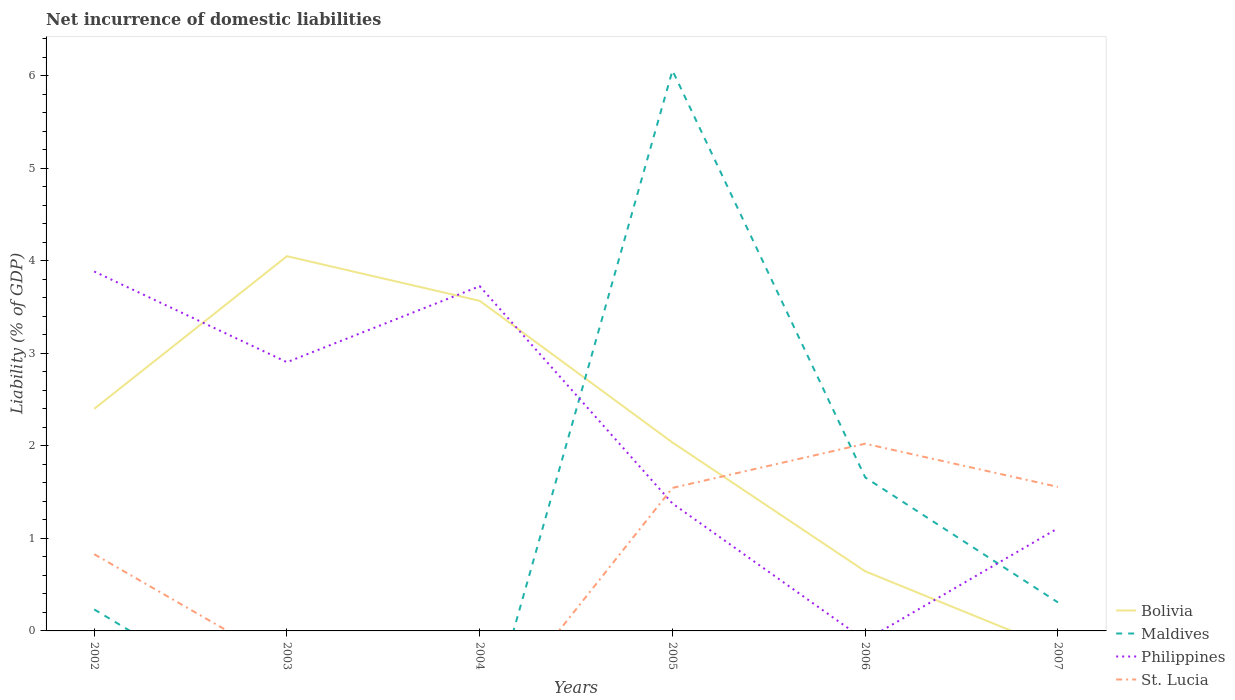How many different coloured lines are there?
Offer a terse response. 4. Is the number of lines equal to the number of legend labels?
Your answer should be compact. No. Across all years, what is the maximum net incurrence of domestic liabilities in St. Lucia?
Offer a terse response. 0. What is the total net incurrence of domestic liabilities in St. Lucia in the graph?
Your answer should be compact. -0.72. What is the difference between the highest and the second highest net incurrence of domestic liabilities in St. Lucia?
Your answer should be very brief. 2.02. What is the difference between the highest and the lowest net incurrence of domestic liabilities in St. Lucia?
Your answer should be very brief. 3. Is the net incurrence of domestic liabilities in Maldives strictly greater than the net incurrence of domestic liabilities in Bolivia over the years?
Offer a terse response. No. Does the graph contain grids?
Provide a succinct answer. No. Where does the legend appear in the graph?
Ensure brevity in your answer.  Bottom right. How are the legend labels stacked?
Make the answer very short. Vertical. What is the title of the graph?
Offer a very short reply. Net incurrence of domestic liabilities. What is the label or title of the X-axis?
Keep it short and to the point. Years. What is the label or title of the Y-axis?
Your response must be concise. Liability (% of GDP). What is the Liability (% of GDP) of Bolivia in 2002?
Offer a very short reply. 2.4. What is the Liability (% of GDP) of Maldives in 2002?
Provide a succinct answer. 0.23. What is the Liability (% of GDP) of Philippines in 2002?
Make the answer very short. 3.88. What is the Liability (% of GDP) in St. Lucia in 2002?
Your answer should be very brief. 0.83. What is the Liability (% of GDP) of Bolivia in 2003?
Provide a short and direct response. 4.05. What is the Liability (% of GDP) of Philippines in 2003?
Ensure brevity in your answer.  2.9. What is the Liability (% of GDP) in Bolivia in 2004?
Offer a terse response. 3.57. What is the Liability (% of GDP) of Maldives in 2004?
Your answer should be very brief. 0. What is the Liability (% of GDP) of Philippines in 2004?
Make the answer very short. 3.72. What is the Liability (% of GDP) of Bolivia in 2005?
Offer a very short reply. 2.04. What is the Liability (% of GDP) of Maldives in 2005?
Provide a short and direct response. 6.06. What is the Liability (% of GDP) of Philippines in 2005?
Keep it short and to the point. 1.38. What is the Liability (% of GDP) of St. Lucia in 2005?
Your response must be concise. 1.55. What is the Liability (% of GDP) of Bolivia in 2006?
Offer a very short reply. 0.64. What is the Liability (% of GDP) in Maldives in 2006?
Make the answer very short. 1.66. What is the Liability (% of GDP) of St. Lucia in 2006?
Make the answer very short. 2.02. What is the Liability (% of GDP) in Bolivia in 2007?
Give a very brief answer. 0. What is the Liability (% of GDP) in Maldives in 2007?
Your answer should be very brief. 0.31. What is the Liability (% of GDP) of Philippines in 2007?
Provide a succinct answer. 1.11. What is the Liability (% of GDP) of St. Lucia in 2007?
Give a very brief answer. 1.56. Across all years, what is the maximum Liability (% of GDP) in Bolivia?
Your response must be concise. 4.05. Across all years, what is the maximum Liability (% of GDP) in Maldives?
Give a very brief answer. 6.06. Across all years, what is the maximum Liability (% of GDP) in Philippines?
Offer a very short reply. 3.88. Across all years, what is the maximum Liability (% of GDP) in St. Lucia?
Give a very brief answer. 2.02. Across all years, what is the minimum Liability (% of GDP) in Bolivia?
Give a very brief answer. 0. Across all years, what is the minimum Liability (% of GDP) of Maldives?
Provide a succinct answer. 0. Across all years, what is the minimum Liability (% of GDP) in St. Lucia?
Offer a terse response. 0. What is the total Liability (% of GDP) in Bolivia in the graph?
Your answer should be very brief. 12.7. What is the total Liability (% of GDP) of Maldives in the graph?
Offer a very short reply. 8.25. What is the total Liability (% of GDP) in Philippines in the graph?
Your answer should be very brief. 13. What is the total Liability (% of GDP) of St. Lucia in the graph?
Offer a very short reply. 5.95. What is the difference between the Liability (% of GDP) in Bolivia in 2002 and that in 2003?
Make the answer very short. -1.65. What is the difference between the Liability (% of GDP) in Philippines in 2002 and that in 2003?
Make the answer very short. 0.98. What is the difference between the Liability (% of GDP) in Bolivia in 2002 and that in 2004?
Provide a succinct answer. -1.17. What is the difference between the Liability (% of GDP) in Philippines in 2002 and that in 2004?
Offer a very short reply. 0.16. What is the difference between the Liability (% of GDP) in Bolivia in 2002 and that in 2005?
Offer a very short reply. 0.36. What is the difference between the Liability (% of GDP) in Maldives in 2002 and that in 2005?
Your answer should be very brief. -5.82. What is the difference between the Liability (% of GDP) in Philippines in 2002 and that in 2005?
Provide a succinct answer. 2.51. What is the difference between the Liability (% of GDP) of St. Lucia in 2002 and that in 2005?
Make the answer very short. -0.72. What is the difference between the Liability (% of GDP) of Bolivia in 2002 and that in 2006?
Give a very brief answer. 1.76. What is the difference between the Liability (% of GDP) in Maldives in 2002 and that in 2006?
Provide a succinct answer. -1.43. What is the difference between the Liability (% of GDP) of St. Lucia in 2002 and that in 2006?
Offer a very short reply. -1.19. What is the difference between the Liability (% of GDP) of Maldives in 2002 and that in 2007?
Ensure brevity in your answer.  -0.08. What is the difference between the Liability (% of GDP) in Philippines in 2002 and that in 2007?
Your response must be concise. 2.77. What is the difference between the Liability (% of GDP) of St. Lucia in 2002 and that in 2007?
Your answer should be very brief. -0.73. What is the difference between the Liability (% of GDP) in Bolivia in 2003 and that in 2004?
Make the answer very short. 0.48. What is the difference between the Liability (% of GDP) in Philippines in 2003 and that in 2004?
Make the answer very short. -0.82. What is the difference between the Liability (% of GDP) of Bolivia in 2003 and that in 2005?
Keep it short and to the point. 2.01. What is the difference between the Liability (% of GDP) of Philippines in 2003 and that in 2005?
Keep it short and to the point. 1.53. What is the difference between the Liability (% of GDP) of Bolivia in 2003 and that in 2006?
Your answer should be very brief. 3.4. What is the difference between the Liability (% of GDP) in Philippines in 2003 and that in 2007?
Keep it short and to the point. 1.79. What is the difference between the Liability (% of GDP) in Bolivia in 2004 and that in 2005?
Offer a very short reply. 1.53. What is the difference between the Liability (% of GDP) in Philippines in 2004 and that in 2005?
Offer a terse response. 2.35. What is the difference between the Liability (% of GDP) in Bolivia in 2004 and that in 2006?
Provide a succinct answer. 2.92. What is the difference between the Liability (% of GDP) in Philippines in 2004 and that in 2007?
Keep it short and to the point. 2.61. What is the difference between the Liability (% of GDP) in Bolivia in 2005 and that in 2006?
Give a very brief answer. 1.39. What is the difference between the Liability (% of GDP) of Maldives in 2005 and that in 2006?
Keep it short and to the point. 4.4. What is the difference between the Liability (% of GDP) in St. Lucia in 2005 and that in 2006?
Ensure brevity in your answer.  -0.48. What is the difference between the Liability (% of GDP) of Maldives in 2005 and that in 2007?
Give a very brief answer. 5.75. What is the difference between the Liability (% of GDP) of Philippines in 2005 and that in 2007?
Your response must be concise. 0.27. What is the difference between the Liability (% of GDP) of St. Lucia in 2005 and that in 2007?
Your answer should be compact. -0.01. What is the difference between the Liability (% of GDP) of Maldives in 2006 and that in 2007?
Keep it short and to the point. 1.35. What is the difference between the Liability (% of GDP) in St. Lucia in 2006 and that in 2007?
Make the answer very short. 0.47. What is the difference between the Liability (% of GDP) in Bolivia in 2002 and the Liability (% of GDP) in Philippines in 2003?
Your answer should be compact. -0.5. What is the difference between the Liability (% of GDP) of Maldives in 2002 and the Liability (% of GDP) of Philippines in 2003?
Your response must be concise. -2.67. What is the difference between the Liability (% of GDP) of Bolivia in 2002 and the Liability (% of GDP) of Philippines in 2004?
Keep it short and to the point. -1.32. What is the difference between the Liability (% of GDP) in Maldives in 2002 and the Liability (% of GDP) in Philippines in 2004?
Keep it short and to the point. -3.49. What is the difference between the Liability (% of GDP) of Bolivia in 2002 and the Liability (% of GDP) of Maldives in 2005?
Give a very brief answer. -3.66. What is the difference between the Liability (% of GDP) in Bolivia in 2002 and the Liability (% of GDP) in Philippines in 2005?
Offer a very short reply. 1.02. What is the difference between the Liability (% of GDP) in Bolivia in 2002 and the Liability (% of GDP) in St. Lucia in 2005?
Your answer should be compact. 0.85. What is the difference between the Liability (% of GDP) in Maldives in 2002 and the Liability (% of GDP) in Philippines in 2005?
Ensure brevity in your answer.  -1.14. What is the difference between the Liability (% of GDP) of Maldives in 2002 and the Liability (% of GDP) of St. Lucia in 2005?
Your answer should be very brief. -1.31. What is the difference between the Liability (% of GDP) in Philippines in 2002 and the Liability (% of GDP) in St. Lucia in 2005?
Ensure brevity in your answer.  2.34. What is the difference between the Liability (% of GDP) in Bolivia in 2002 and the Liability (% of GDP) in Maldives in 2006?
Your answer should be very brief. 0.74. What is the difference between the Liability (% of GDP) in Bolivia in 2002 and the Liability (% of GDP) in St. Lucia in 2006?
Provide a succinct answer. 0.38. What is the difference between the Liability (% of GDP) of Maldives in 2002 and the Liability (% of GDP) of St. Lucia in 2006?
Provide a succinct answer. -1.79. What is the difference between the Liability (% of GDP) in Philippines in 2002 and the Liability (% of GDP) in St. Lucia in 2006?
Keep it short and to the point. 1.86. What is the difference between the Liability (% of GDP) of Bolivia in 2002 and the Liability (% of GDP) of Maldives in 2007?
Keep it short and to the point. 2.09. What is the difference between the Liability (% of GDP) in Bolivia in 2002 and the Liability (% of GDP) in Philippines in 2007?
Your answer should be very brief. 1.29. What is the difference between the Liability (% of GDP) of Bolivia in 2002 and the Liability (% of GDP) of St. Lucia in 2007?
Ensure brevity in your answer.  0.84. What is the difference between the Liability (% of GDP) of Maldives in 2002 and the Liability (% of GDP) of Philippines in 2007?
Your answer should be very brief. -0.88. What is the difference between the Liability (% of GDP) in Maldives in 2002 and the Liability (% of GDP) in St. Lucia in 2007?
Give a very brief answer. -1.32. What is the difference between the Liability (% of GDP) of Philippines in 2002 and the Liability (% of GDP) of St. Lucia in 2007?
Your answer should be compact. 2.33. What is the difference between the Liability (% of GDP) of Bolivia in 2003 and the Liability (% of GDP) of Philippines in 2004?
Ensure brevity in your answer.  0.32. What is the difference between the Liability (% of GDP) in Bolivia in 2003 and the Liability (% of GDP) in Maldives in 2005?
Your answer should be very brief. -2.01. What is the difference between the Liability (% of GDP) of Bolivia in 2003 and the Liability (% of GDP) of Philippines in 2005?
Keep it short and to the point. 2.67. What is the difference between the Liability (% of GDP) in Bolivia in 2003 and the Liability (% of GDP) in St. Lucia in 2005?
Your answer should be compact. 2.5. What is the difference between the Liability (% of GDP) in Philippines in 2003 and the Liability (% of GDP) in St. Lucia in 2005?
Your answer should be very brief. 1.36. What is the difference between the Liability (% of GDP) of Bolivia in 2003 and the Liability (% of GDP) of Maldives in 2006?
Provide a succinct answer. 2.39. What is the difference between the Liability (% of GDP) in Bolivia in 2003 and the Liability (% of GDP) in St. Lucia in 2006?
Your answer should be very brief. 2.03. What is the difference between the Liability (% of GDP) in Philippines in 2003 and the Liability (% of GDP) in St. Lucia in 2006?
Your answer should be compact. 0.88. What is the difference between the Liability (% of GDP) in Bolivia in 2003 and the Liability (% of GDP) in Maldives in 2007?
Offer a terse response. 3.74. What is the difference between the Liability (% of GDP) in Bolivia in 2003 and the Liability (% of GDP) in Philippines in 2007?
Your answer should be very brief. 2.94. What is the difference between the Liability (% of GDP) in Bolivia in 2003 and the Liability (% of GDP) in St. Lucia in 2007?
Offer a very short reply. 2.49. What is the difference between the Liability (% of GDP) in Philippines in 2003 and the Liability (% of GDP) in St. Lucia in 2007?
Offer a terse response. 1.35. What is the difference between the Liability (% of GDP) of Bolivia in 2004 and the Liability (% of GDP) of Maldives in 2005?
Provide a succinct answer. -2.49. What is the difference between the Liability (% of GDP) in Bolivia in 2004 and the Liability (% of GDP) in Philippines in 2005?
Ensure brevity in your answer.  2.19. What is the difference between the Liability (% of GDP) of Bolivia in 2004 and the Liability (% of GDP) of St. Lucia in 2005?
Offer a terse response. 2.02. What is the difference between the Liability (% of GDP) in Philippines in 2004 and the Liability (% of GDP) in St. Lucia in 2005?
Give a very brief answer. 2.18. What is the difference between the Liability (% of GDP) in Bolivia in 2004 and the Liability (% of GDP) in Maldives in 2006?
Your answer should be compact. 1.91. What is the difference between the Liability (% of GDP) in Bolivia in 2004 and the Liability (% of GDP) in St. Lucia in 2006?
Provide a succinct answer. 1.54. What is the difference between the Liability (% of GDP) of Philippines in 2004 and the Liability (% of GDP) of St. Lucia in 2006?
Give a very brief answer. 1.7. What is the difference between the Liability (% of GDP) in Bolivia in 2004 and the Liability (% of GDP) in Maldives in 2007?
Provide a short and direct response. 3.26. What is the difference between the Liability (% of GDP) in Bolivia in 2004 and the Liability (% of GDP) in Philippines in 2007?
Ensure brevity in your answer.  2.46. What is the difference between the Liability (% of GDP) in Bolivia in 2004 and the Liability (% of GDP) in St. Lucia in 2007?
Keep it short and to the point. 2.01. What is the difference between the Liability (% of GDP) in Philippines in 2004 and the Liability (% of GDP) in St. Lucia in 2007?
Give a very brief answer. 2.17. What is the difference between the Liability (% of GDP) of Bolivia in 2005 and the Liability (% of GDP) of Maldives in 2006?
Your answer should be very brief. 0.38. What is the difference between the Liability (% of GDP) of Bolivia in 2005 and the Liability (% of GDP) of St. Lucia in 2006?
Keep it short and to the point. 0.01. What is the difference between the Liability (% of GDP) of Maldives in 2005 and the Liability (% of GDP) of St. Lucia in 2006?
Ensure brevity in your answer.  4.03. What is the difference between the Liability (% of GDP) of Philippines in 2005 and the Liability (% of GDP) of St. Lucia in 2006?
Offer a very short reply. -0.65. What is the difference between the Liability (% of GDP) of Bolivia in 2005 and the Liability (% of GDP) of Maldives in 2007?
Give a very brief answer. 1.73. What is the difference between the Liability (% of GDP) of Bolivia in 2005 and the Liability (% of GDP) of Philippines in 2007?
Ensure brevity in your answer.  0.93. What is the difference between the Liability (% of GDP) in Bolivia in 2005 and the Liability (% of GDP) in St. Lucia in 2007?
Your answer should be compact. 0.48. What is the difference between the Liability (% of GDP) of Maldives in 2005 and the Liability (% of GDP) of Philippines in 2007?
Make the answer very short. 4.95. What is the difference between the Liability (% of GDP) in Maldives in 2005 and the Liability (% of GDP) in St. Lucia in 2007?
Your response must be concise. 4.5. What is the difference between the Liability (% of GDP) of Philippines in 2005 and the Liability (% of GDP) of St. Lucia in 2007?
Provide a short and direct response. -0.18. What is the difference between the Liability (% of GDP) in Bolivia in 2006 and the Liability (% of GDP) in Maldives in 2007?
Provide a short and direct response. 0.34. What is the difference between the Liability (% of GDP) in Bolivia in 2006 and the Liability (% of GDP) in Philippines in 2007?
Your answer should be compact. -0.47. What is the difference between the Liability (% of GDP) of Bolivia in 2006 and the Liability (% of GDP) of St. Lucia in 2007?
Your answer should be compact. -0.91. What is the difference between the Liability (% of GDP) of Maldives in 2006 and the Liability (% of GDP) of Philippines in 2007?
Give a very brief answer. 0.55. What is the difference between the Liability (% of GDP) of Maldives in 2006 and the Liability (% of GDP) of St. Lucia in 2007?
Offer a terse response. 0.1. What is the average Liability (% of GDP) in Bolivia per year?
Offer a terse response. 2.12. What is the average Liability (% of GDP) in Maldives per year?
Give a very brief answer. 1.38. What is the average Liability (% of GDP) in Philippines per year?
Provide a short and direct response. 2.17. In the year 2002, what is the difference between the Liability (% of GDP) in Bolivia and Liability (% of GDP) in Maldives?
Your answer should be very brief. 2.17. In the year 2002, what is the difference between the Liability (% of GDP) of Bolivia and Liability (% of GDP) of Philippines?
Your answer should be very brief. -1.48. In the year 2002, what is the difference between the Liability (% of GDP) of Bolivia and Liability (% of GDP) of St. Lucia?
Provide a short and direct response. 1.57. In the year 2002, what is the difference between the Liability (% of GDP) of Maldives and Liability (% of GDP) of Philippines?
Offer a terse response. -3.65. In the year 2002, what is the difference between the Liability (% of GDP) of Maldives and Liability (% of GDP) of St. Lucia?
Provide a short and direct response. -0.6. In the year 2002, what is the difference between the Liability (% of GDP) of Philippines and Liability (% of GDP) of St. Lucia?
Your response must be concise. 3.05. In the year 2003, what is the difference between the Liability (% of GDP) in Bolivia and Liability (% of GDP) in Philippines?
Your answer should be compact. 1.15. In the year 2004, what is the difference between the Liability (% of GDP) in Bolivia and Liability (% of GDP) in Philippines?
Provide a succinct answer. -0.16. In the year 2005, what is the difference between the Liability (% of GDP) in Bolivia and Liability (% of GDP) in Maldives?
Offer a very short reply. -4.02. In the year 2005, what is the difference between the Liability (% of GDP) of Bolivia and Liability (% of GDP) of Philippines?
Provide a short and direct response. 0.66. In the year 2005, what is the difference between the Liability (% of GDP) of Bolivia and Liability (% of GDP) of St. Lucia?
Your answer should be compact. 0.49. In the year 2005, what is the difference between the Liability (% of GDP) of Maldives and Liability (% of GDP) of Philippines?
Ensure brevity in your answer.  4.68. In the year 2005, what is the difference between the Liability (% of GDP) of Maldives and Liability (% of GDP) of St. Lucia?
Give a very brief answer. 4.51. In the year 2005, what is the difference between the Liability (% of GDP) in Philippines and Liability (% of GDP) in St. Lucia?
Your answer should be compact. -0.17. In the year 2006, what is the difference between the Liability (% of GDP) of Bolivia and Liability (% of GDP) of Maldives?
Your response must be concise. -1.01. In the year 2006, what is the difference between the Liability (% of GDP) of Bolivia and Liability (% of GDP) of St. Lucia?
Offer a very short reply. -1.38. In the year 2006, what is the difference between the Liability (% of GDP) of Maldives and Liability (% of GDP) of St. Lucia?
Make the answer very short. -0.36. In the year 2007, what is the difference between the Liability (% of GDP) in Maldives and Liability (% of GDP) in Philippines?
Offer a very short reply. -0.8. In the year 2007, what is the difference between the Liability (% of GDP) in Maldives and Liability (% of GDP) in St. Lucia?
Your answer should be very brief. -1.25. In the year 2007, what is the difference between the Liability (% of GDP) in Philippines and Liability (% of GDP) in St. Lucia?
Your answer should be very brief. -0.45. What is the ratio of the Liability (% of GDP) in Bolivia in 2002 to that in 2003?
Offer a very short reply. 0.59. What is the ratio of the Liability (% of GDP) of Philippines in 2002 to that in 2003?
Offer a terse response. 1.34. What is the ratio of the Liability (% of GDP) of Bolivia in 2002 to that in 2004?
Your response must be concise. 0.67. What is the ratio of the Liability (% of GDP) of Philippines in 2002 to that in 2004?
Give a very brief answer. 1.04. What is the ratio of the Liability (% of GDP) in Bolivia in 2002 to that in 2005?
Offer a very short reply. 1.18. What is the ratio of the Liability (% of GDP) of Maldives in 2002 to that in 2005?
Offer a terse response. 0.04. What is the ratio of the Liability (% of GDP) in Philippines in 2002 to that in 2005?
Provide a succinct answer. 2.82. What is the ratio of the Liability (% of GDP) in St. Lucia in 2002 to that in 2005?
Your answer should be compact. 0.54. What is the ratio of the Liability (% of GDP) in Bolivia in 2002 to that in 2006?
Provide a short and direct response. 3.73. What is the ratio of the Liability (% of GDP) in Maldives in 2002 to that in 2006?
Ensure brevity in your answer.  0.14. What is the ratio of the Liability (% of GDP) in St. Lucia in 2002 to that in 2006?
Provide a succinct answer. 0.41. What is the ratio of the Liability (% of GDP) of Maldives in 2002 to that in 2007?
Keep it short and to the point. 0.76. What is the ratio of the Liability (% of GDP) of Philippines in 2002 to that in 2007?
Your response must be concise. 3.5. What is the ratio of the Liability (% of GDP) of St. Lucia in 2002 to that in 2007?
Offer a terse response. 0.53. What is the ratio of the Liability (% of GDP) of Bolivia in 2003 to that in 2004?
Give a very brief answer. 1.14. What is the ratio of the Liability (% of GDP) of Philippines in 2003 to that in 2004?
Offer a very short reply. 0.78. What is the ratio of the Liability (% of GDP) of Bolivia in 2003 to that in 2005?
Keep it short and to the point. 1.99. What is the ratio of the Liability (% of GDP) of Philippines in 2003 to that in 2005?
Your response must be concise. 2.11. What is the ratio of the Liability (% of GDP) of Bolivia in 2003 to that in 2006?
Provide a succinct answer. 6.28. What is the ratio of the Liability (% of GDP) in Philippines in 2003 to that in 2007?
Your answer should be compact. 2.62. What is the ratio of the Liability (% of GDP) in Bolivia in 2004 to that in 2005?
Give a very brief answer. 1.75. What is the ratio of the Liability (% of GDP) in Philippines in 2004 to that in 2005?
Offer a terse response. 2.71. What is the ratio of the Liability (% of GDP) of Bolivia in 2004 to that in 2006?
Offer a very short reply. 5.54. What is the ratio of the Liability (% of GDP) in Philippines in 2004 to that in 2007?
Your answer should be compact. 3.36. What is the ratio of the Liability (% of GDP) of Bolivia in 2005 to that in 2006?
Ensure brevity in your answer.  3.16. What is the ratio of the Liability (% of GDP) of Maldives in 2005 to that in 2006?
Your answer should be compact. 3.65. What is the ratio of the Liability (% of GDP) of St. Lucia in 2005 to that in 2006?
Make the answer very short. 0.76. What is the ratio of the Liability (% of GDP) of Maldives in 2005 to that in 2007?
Provide a succinct answer. 19.67. What is the ratio of the Liability (% of GDP) in Philippines in 2005 to that in 2007?
Make the answer very short. 1.24. What is the ratio of the Liability (% of GDP) in Maldives in 2006 to that in 2007?
Ensure brevity in your answer.  5.39. What is the ratio of the Liability (% of GDP) of St. Lucia in 2006 to that in 2007?
Your answer should be compact. 1.3. What is the difference between the highest and the second highest Liability (% of GDP) of Bolivia?
Provide a short and direct response. 0.48. What is the difference between the highest and the second highest Liability (% of GDP) of Maldives?
Your answer should be compact. 4.4. What is the difference between the highest and the second highest Liability (% of GDP) of Philippines?
Ensure brevity in your answer.  0.16. What is the difference between the highest and the second highest Liability (% of GDP) in St. Lucia?
Provide a succinct answer. 0.47. What is the difference between the highest and the lowest Liability (% of GDP) of Bolivia?
Keep it short and to the point. 4.05. What is the difference between the highest and the lowest Liability (% of GDP) in Maldives?
Offer a very short reply. 6.05. What is the difference between the highest and the lowest Liability (% of GDP) of Philippines?
Provide a short and direct response. 3.88. What is the difference between the highest and the lowest Liability (% of GDP) in St. Lucia?
Provide a short and direct response. 2.02. 